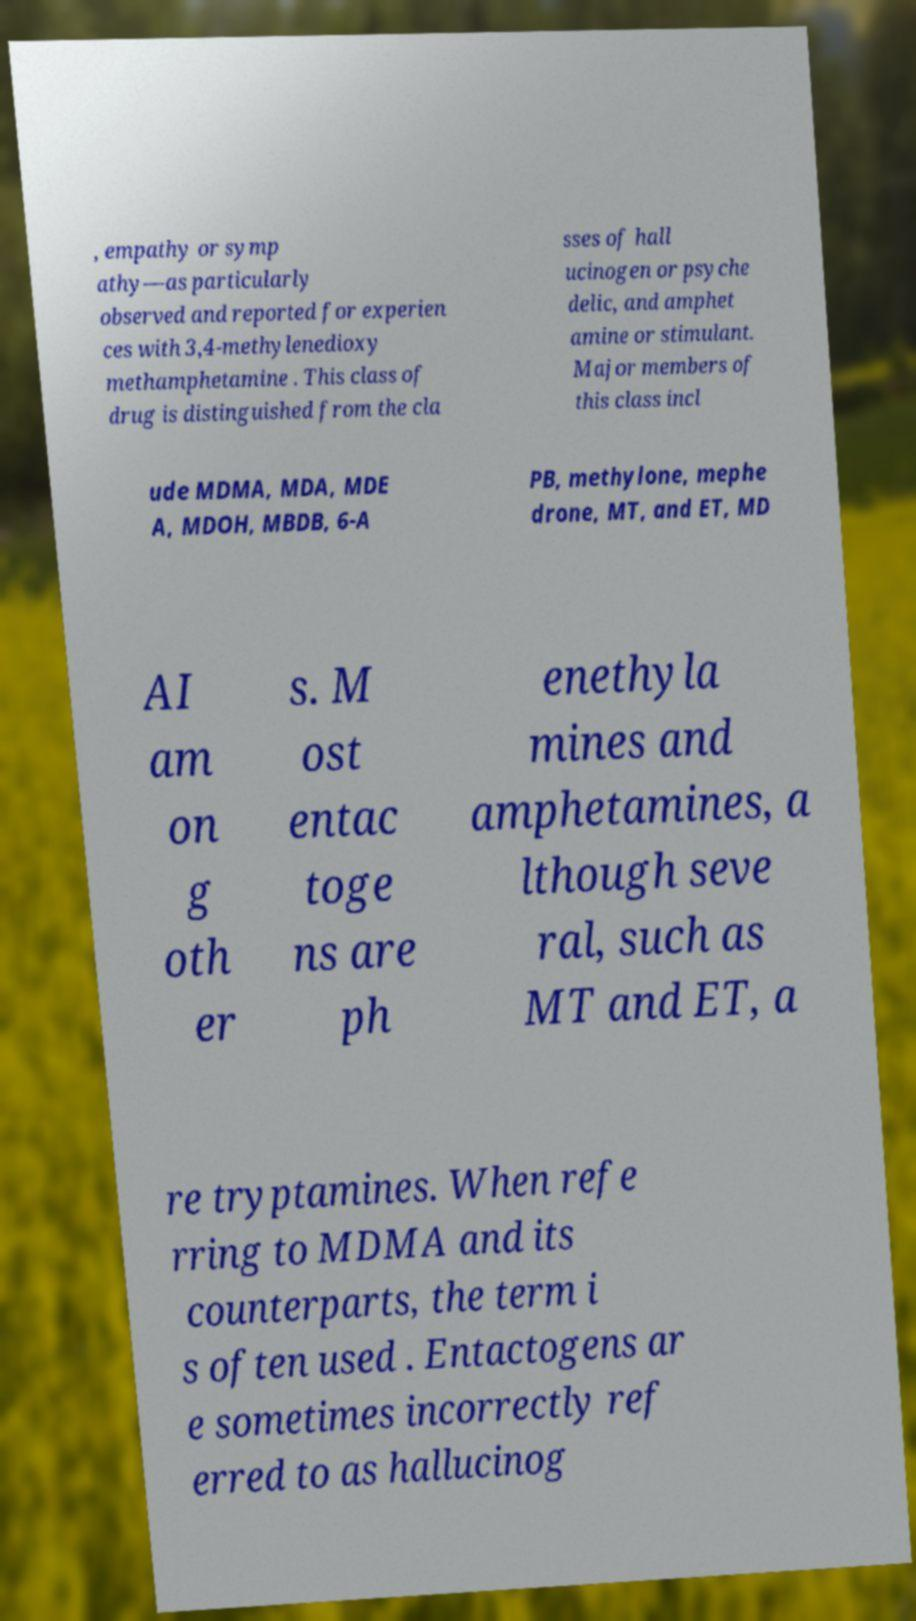I need the written content from this picture converted into text. Can you do that? , empathy or symp athy—as particularly observed and reported for experien ces with 3,4-methylenedioxy methamphetamine . This class of drug is distinguished from the cla sses of hall ucinogen or psyche delic, and amphet amine or stimulant. Major members of this class incl ude MDMA, MDA, MDE A, MDOH, MBDB, 6-A PB, methylone, mephe drone, MT, and ET, MD AI am on g oth er s. M ost entac toge ns are ph enethyla mines and amphetamines, a lthough seve ral, such as MT and ET, a re tryptamines. When refe rring to MDMA and its counterparts, the term i s often used . Entactogens ar e sometimes incorrectly ref erred to as hallucinog 